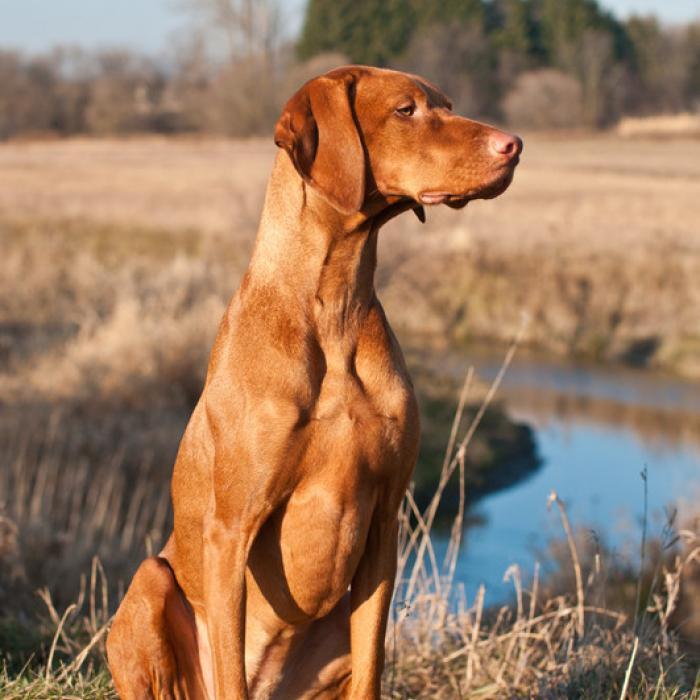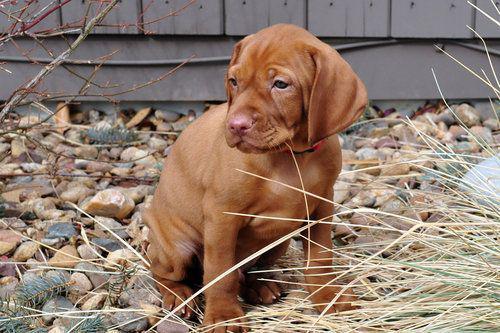The first image is the image on the left, the second image is the image on the right. Evaluate the accuracy of this statement regarding the images: "Each image shows a single dog that is outside and wearing a collar.". Is it true? Answer yes or no. No. The first image is the image on the left, the second image is the image on the right. For the images displayed, is the sentence "The left image contains one dog sitting upright, and the right image contains one dog standing on all fours." factually correct? Answer yes or no. No. 